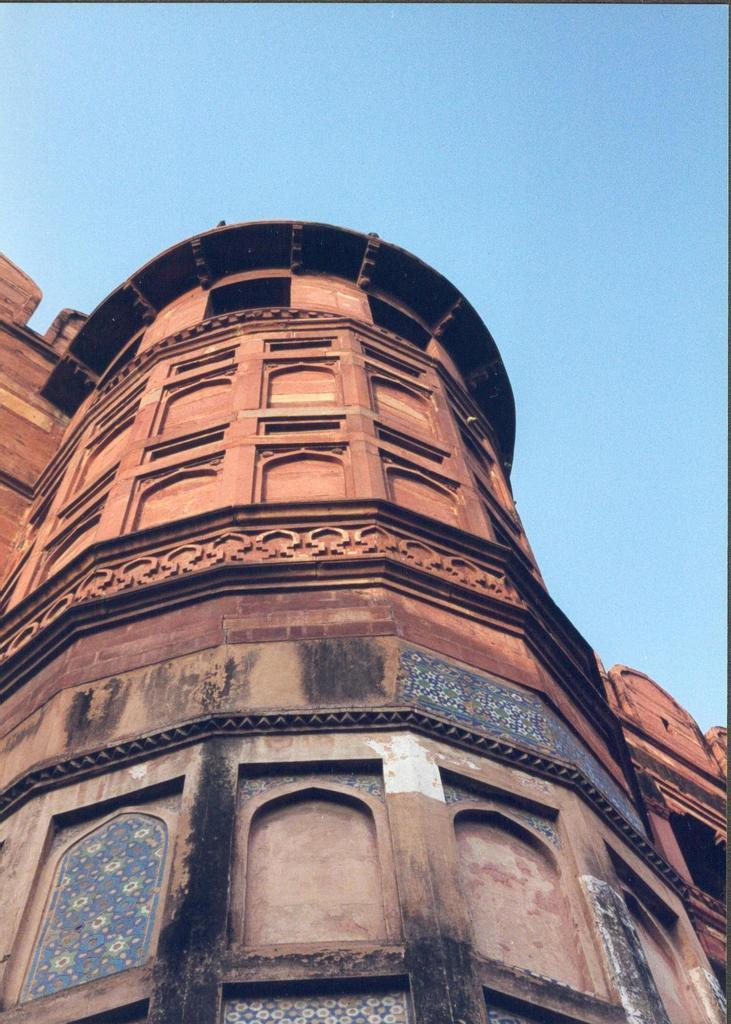What type of structure is present in the image? There is a building in the image. What is the color of the building? The building is brown in color. What can be seen in the background of the image? The blue sky is visible in the background of the image. How many toes are visible on the cheese in the image? There is no cheese or toes present in the image. What type of coach is standing next to the building in the image? There is no coach present in the image; only the building and the blue sky are visible. 